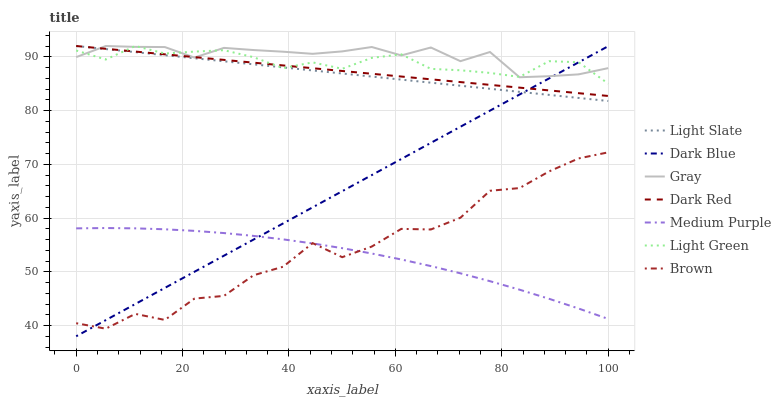Does Medium Purple have the minimum area under the curve?
Answer yes or no. Yes. Does Gray have the maximum area under the curve?
Answer yes or no. Yes. Does Brown have the minimum area under the curve?
Answer yes or no. No. Does Brown have the maximum area under the curve?
Answer yes or no. No. Is Dark Red the smoothest?
Answer yes or no. Yes. Is Brown the roughest?
Answer yes or no. Yes. Is Light Slate the smoothest?
Answer yes or no. No. Is Light Slate the roughest?
Answer yes or no. No. Does Dark Blue have the lowest value?
Answer yes or no. Yes. Does Brown have the lowest value?
Answer yes or no. No. Does Light Green have the highest value?
Answer yes or no. Yes. Does Brown have the highest value?
Answer yes or no. No. Is Brown less than Light Green?
Answer yes or no. Yes. Is Gray greater than Brown?
Answer yes or no. Yes. Does Light Slate intersect Dark Red?
Answer yes or no. Yes. Is Light Slate less than Dark Red?
Answer yes or no. No. Is Light Slate greater than Dark Red?
Answer yes or no. No. Does Brown intersect Light Green?
Answer yes or no. No. 